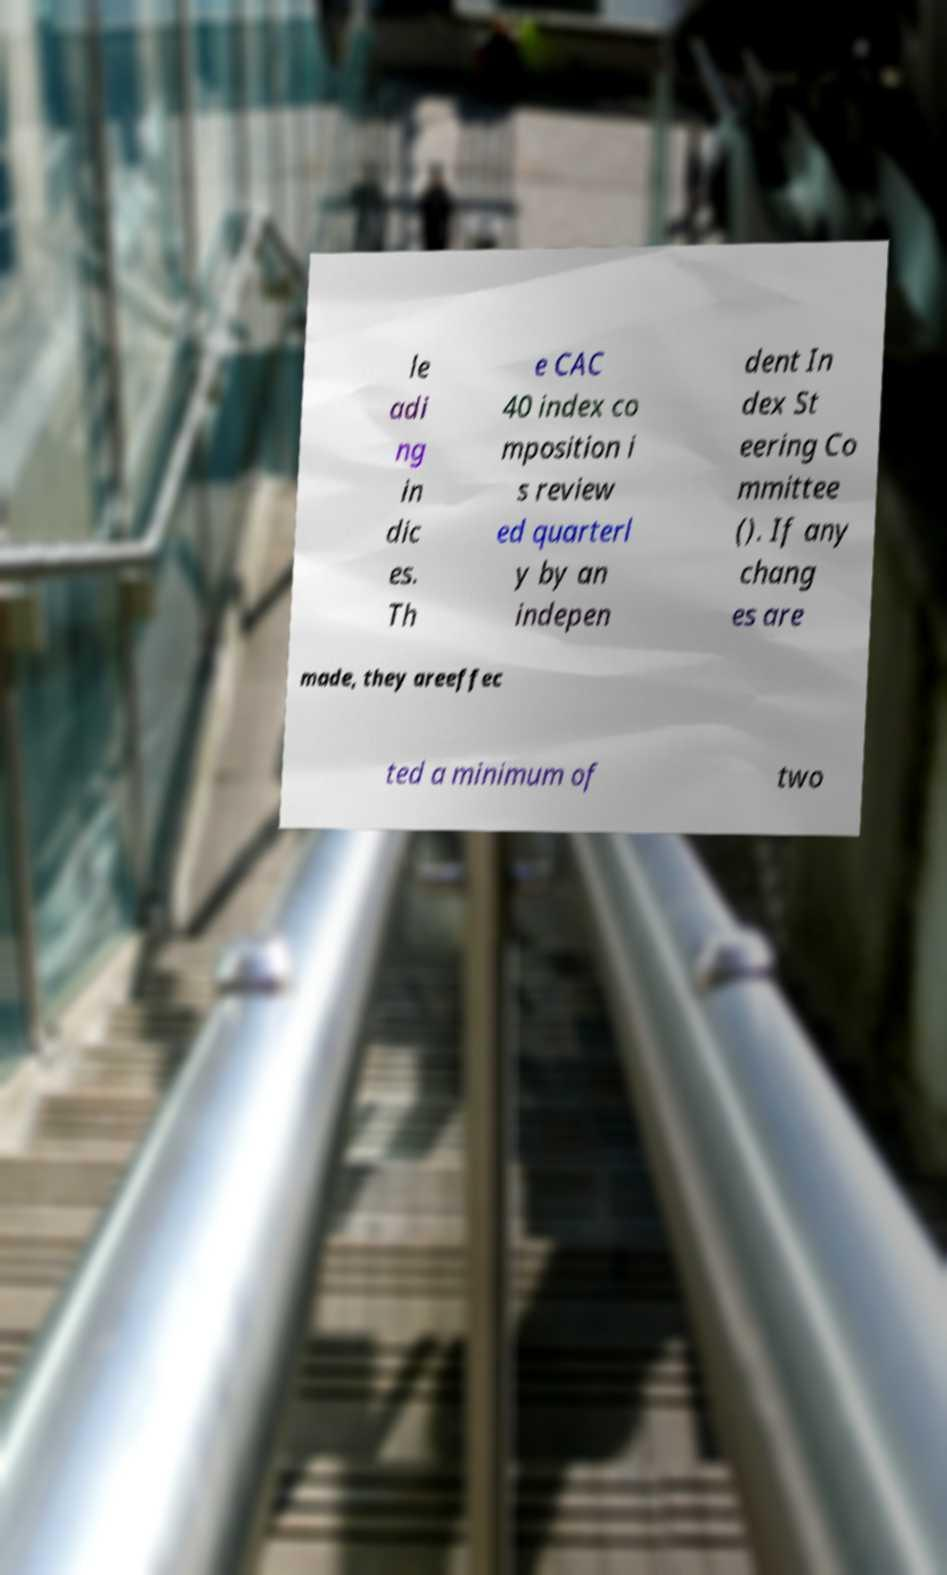There's text embedded in this image that I need extracted. Can you transcribe it verbatim? le adi ng in dic es. Th e CAC 40 index co mposition i s review ed quarterl y by an indepen dent In dex St eering Co mmittee (). If any chang es are made, they areeffec ted a minimum of two 